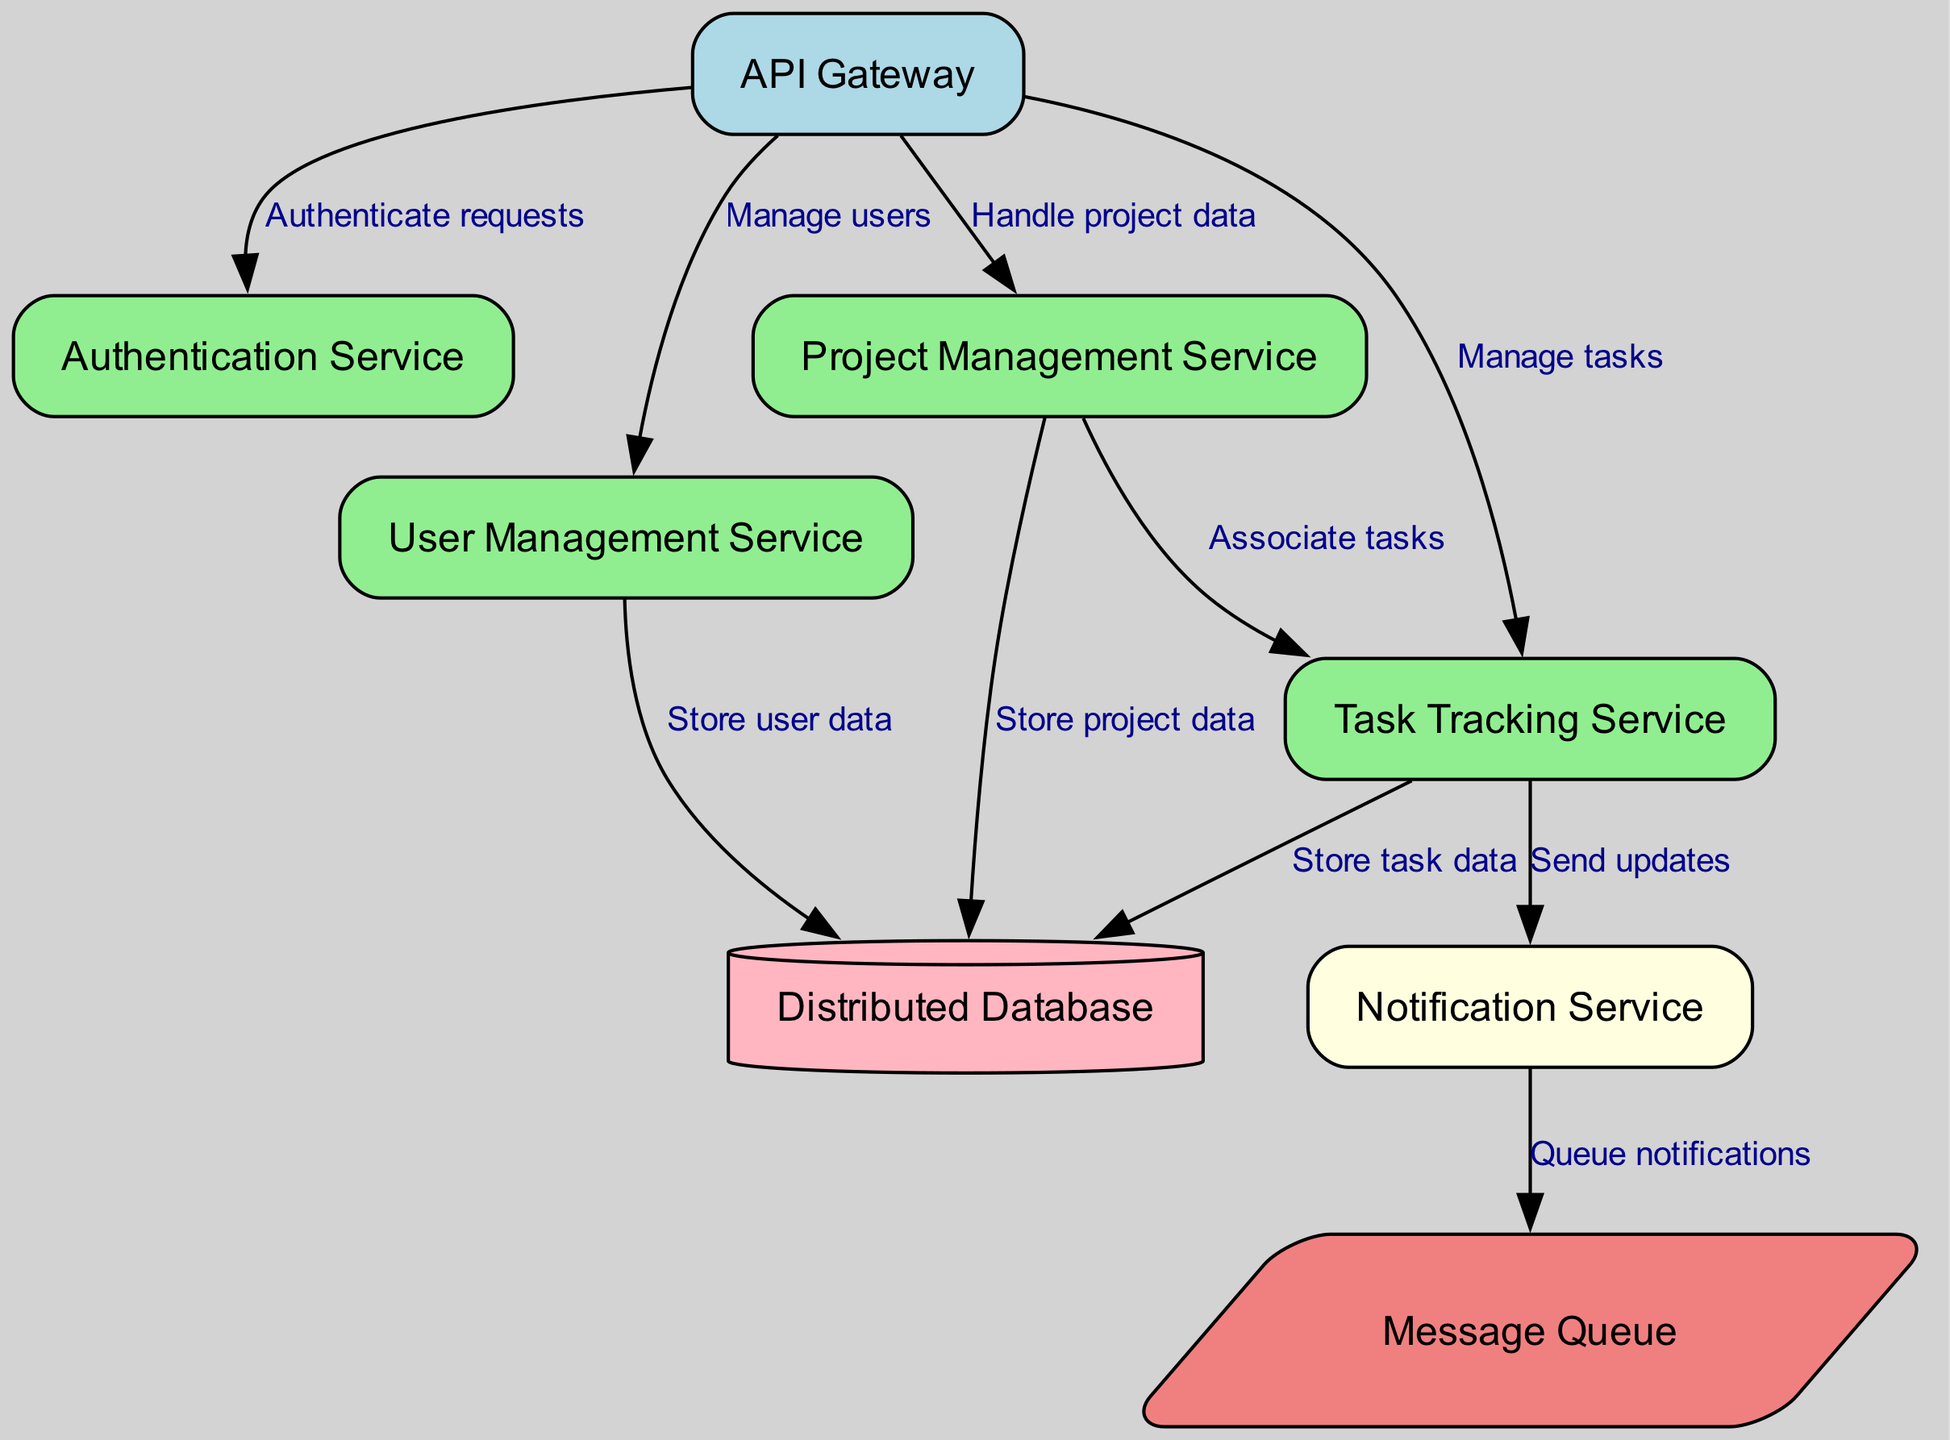What is the label of the node identified as "api_gateway"? The node id "api_gateway" corresponds to the label "API Gateway" in the diagram's nodes section.
Answer: API Gateway How many services interact with the API Gateway? By reviewing the edges connected to "api_gateway," we see there are four direct edges: to the authentication service, user service, project service, and task service. This indicates that four services interact with the API Gateway.
Answer: 4 Which service is responsible for sending updates? The edge from the task service to the notification service indicates that the task service is responsible for sending updates.
Answer: Task Tracking Service What type of database is indicated in the diagram? The label and shape of the database node specify it as a "Distributed Database" shaped like a cylinder, which indicates it's a distributed type.
Answer: Distributed Database Which service stores user data? The edge from user_service to database indicates a direct flow of information, specifically stating that the user service is responsible for storing user data.
Answer: User Management Service Which two services are directly connected through task management? Looking at the edges, the edge connecting project_service to task_service indicates they are directly linked, as the project service associates tasks.
Answer: Project Management Service and Task Tracking Service What is the role of the message queue in this architecture? The edge from notification_service to message_queue suggests that the message queue is utilized for queuing notifications, illustrating its role as an intermediary for message delivery.
Answer: Queue notifications Which service is responsible for managing user accounts? The user_service node clearly indicates that it is dedicated to user management within the system, hence managing user accounts.
Answer: User Management Service How many edges are there leading to the database? There are three edges that point to the database from user_service, project_service, and task_service respectively; thus, calculating them gives us three edges leading to it.
Answer: 3 